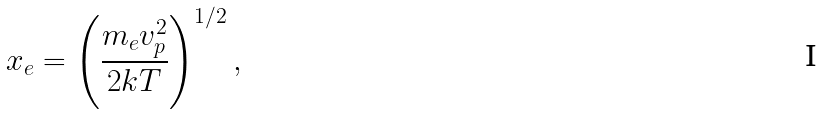Convert formula to latex. <formula><loc_0><loc_0><loc_500><loc_500>x _ { e } = \left ( \frac { m _ { e } v _ { p } ^ { 2 } } { 2 k T } \right ) ^ { 1 / 2 } ,</formula> 